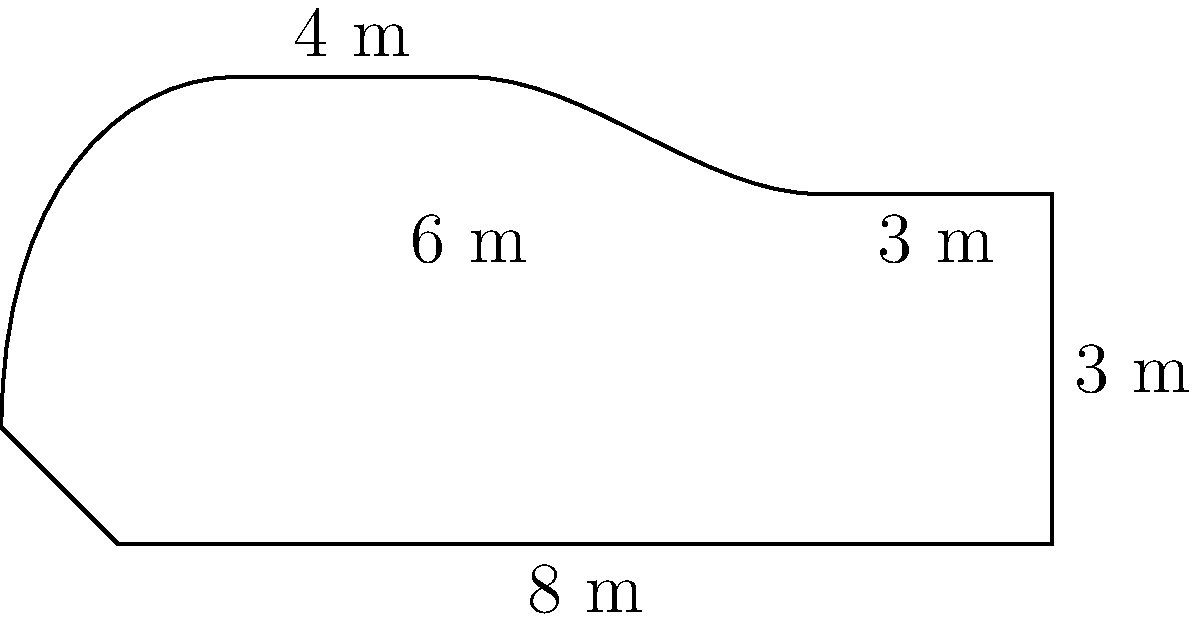A creative piano instructor wants to design a piano-shaped garden to inspire their students. The garden's dimensions are shown in the figure above. Calculate the perimeter of this unique garden, rounding your answer to the nearest meter. How might this garden design encourage students to think creatively about music and space? To calculate the perimeter of the piano-shaped garden, we need to add up all the straight edges and estimate the curved sections:

1. Straight edges:
   - Bottom: 8 m
   - Right side: 3 m
   - Top right: 2 m (8 m - 6 m)
   - Top: 4 m

2. Curved sections (approximations):
   - Top left curve: ≈ 3 m (slightly more than the straight-line distance)
   - Left curve: ≈ 4 m (following the curve from (-1,1) to (0,0))

3. Total perimeter calculation:
   $$ \text{Perimeter} = 8 + 3 + 2 + 4 + 3 + 4 = 24 \text{ m} $$

4. Rounding to the nearest meter:
   The result is already a whole number, so no rounding is necessary.

This garden design encourages creative thinking by:
- Visualizing music in a spatial context
- Exploring the relationship between geometric shapes and musical instruments
- Inspiring discussions about the connection between nature, art, and music
Answer: 24 m 